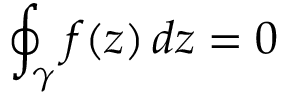Convert formula to latex. <formula><loc_0><loc_0><loc_500><loc_500>\oint _ { \gamma } f ( z ) \, d z = 0</formula> 